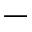<formula> <loc_0><loc_0><loc_500><loc_500>-</formula> 